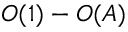<formula> <loc_0><loc_0><loc_500><loc_500>O ( 1 ) - O ( A )</formula> 